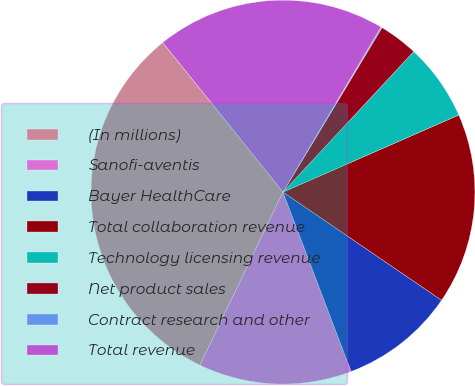Convert chart. <chart><loc_0><loc_0><loc_500><loc_500><pie_chart><fcel>(In millions)<fcel>Sanofi-aventis<fcel>Bayer HealthCare<fcel>Total collaboration revenue<fcel>Technology licensing revenue<fcel>Net product sales<fcel>Contract research and other<fcel>Total revenue<nl><fcel>32.1%<fcel>12.9%<fcel>9.7%<fcel>16.1%<fcel>6.5%<fcel>3.3%<fcel>0.1%<fcel>19.3%<nl></chart> 